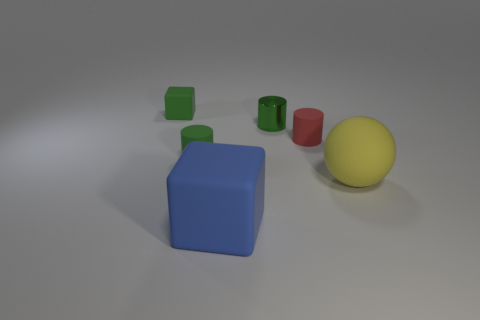Does the small metal thing have the same color as the small matte cube?
Offer a very short reply. Yes. There is a yellow object that is made of the same material as the blue block; what is its shape?
Ensure brevity in your answer.  Sphere. The green block that is made of the same material as the small red cylinder is what size?
Your response must be concise. Small. There is a matte thing that is both in front of the tiny green shiny object and on the left side of the blue rubber object; what shape is it?
Ensure brevity in your answer.  Cylinder. How big is the block in front of the sphere on the right side of the small metal thing?
Your response must be concise. Large. How many other objects are the same color as the small matte block?
Make the answer very short. 2. What material is the blue block?
Ensure brevity in your answer.  Rubber. Are any tiny gray spheres visible?
Offer a terse response. No. Are there an equal number of yellow matte spheres that are in front of the sphere and small green rubber cylinders?
Your response must be concise. No. Is there anything else that has the same material as the big blue thing?
Your answer should be very brief. Yes. 